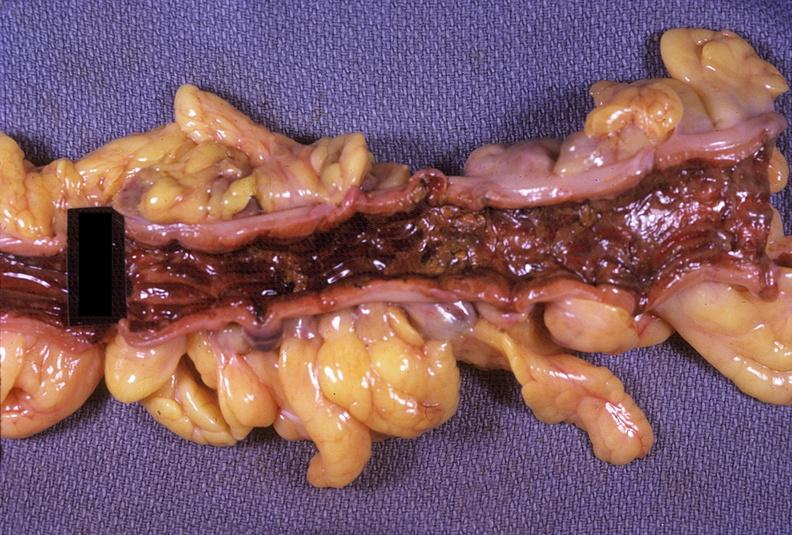does lateral view show colon, ulcerative colitis?
Answer the question using a single word or phrase. No 